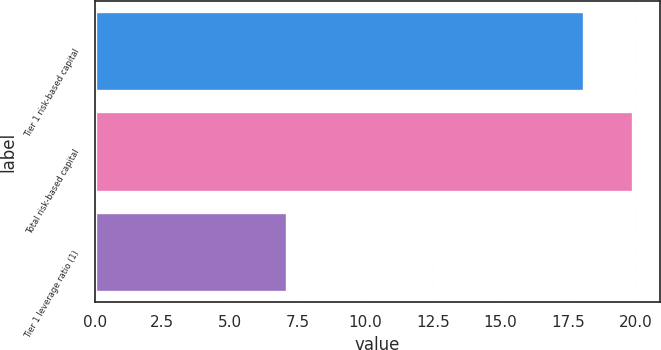Convert chart. <chart><loc_0><loc_0><loc_500><loc_500><bar_chart><fcel>Tier 1 risk-based capital<fcel>Total risk-based capital<fcel>Tier 1 leverage ratio (1)<nl><fcel>18.1<fcel>19.9<fcel>7.1<nl></chart> 